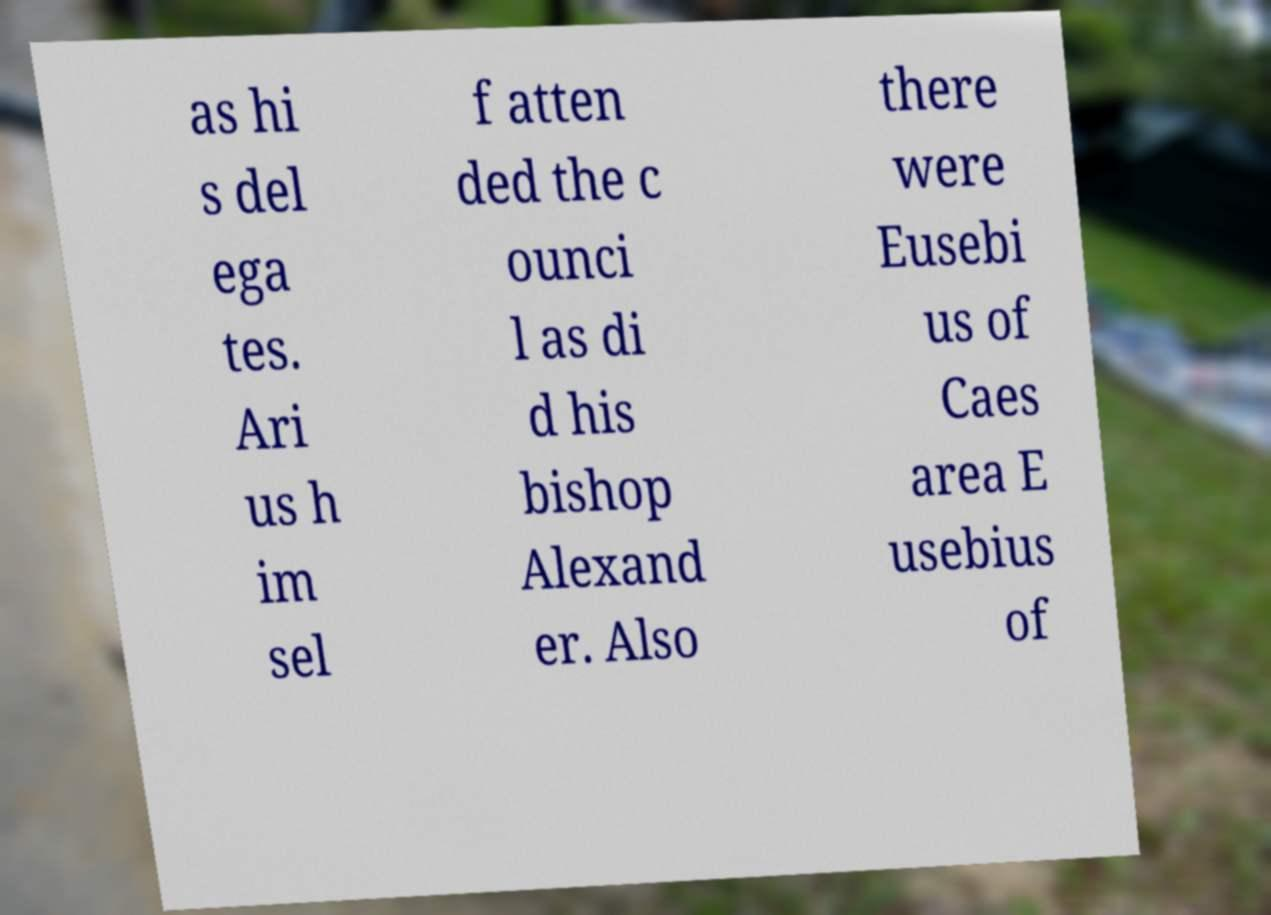Please identify and transcribe the text found in this image. as hi s del ega tes. Ari us h im sel f atten ded the c ounci l as di d his bishop Alexand er. Also there were Eusebi us of Caes area E usebius of 